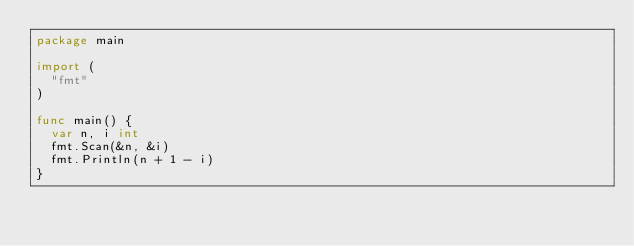<code> <loc_0><loc_0><loc_500><loc_500><_Go_>package main

import (
	"fmt"
)

func main() {
	var n, i int
	fmt.Scan(&n, &i)
	fmt.Println(n + 1 - i)
}
</code> 